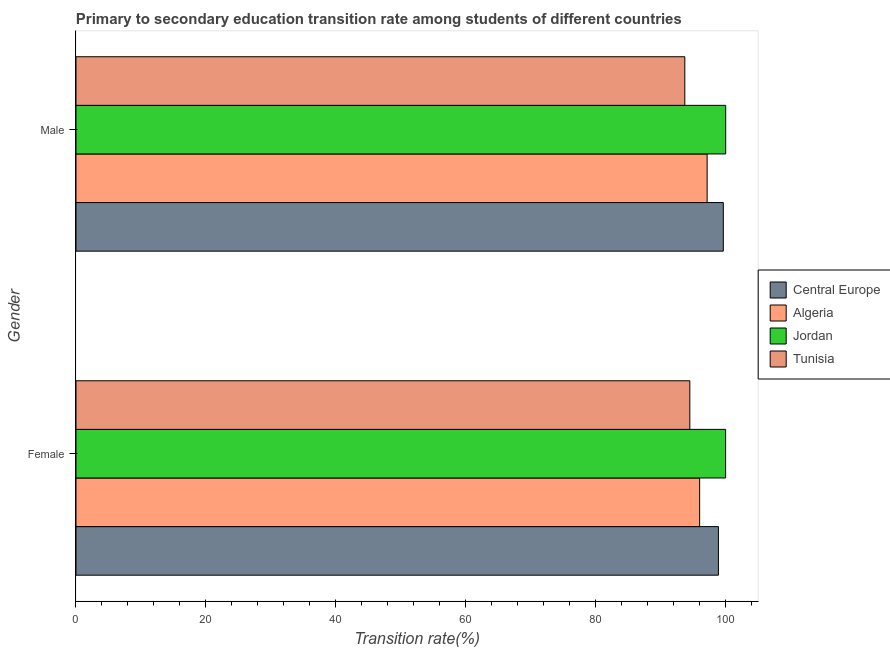How many different coloured bars are there?
Your response must be concise. 4. How many groups of bars are there?
Provide a succinct answer. 2. Are the number of bars on each tick of the Y-axis equal?
Offer a very short reply. Yes. What is the transition rate among male students in Algeria?
Offer a terse response. 97.14. Across all countries, what is the minimum transition rate among male students?
Keep it short and to the point. 93.71. In which country was the transition rate among male students maximum?
Provide a short and direct response. Jordan. In which country was the transition rate among male students minimum?
Your answer should be very brief. Tunisia. What is the total transition rate among female students in the graph?
Provide a succinct answer. 389.34. What is the difference between the transition rate among female students in Algeria and that in Tunisia?
Keep it short and to the point. 1.51. What is the difference between the transition rate among male students in Tunisia and the transition rate among female students in Jordan?
Offer a terse response. -6.28. What is the average transition rate among female students per country?
Provide a succinct answer. 97.33. What is the difference between the transition rate among male students and transition rate among female students in Tunisia?
Ensure brevity in your answer.  -0.77. In how many countries, is the transition rate among female students greater than 92 %?
Make the answer very short. 4. What is the ratio of the transition rate among male students in Algeria to that in Tunisia?
Keep it short and to the point. 1.04. In how many countries, is the transition rate among male students greater than the average transition rate among male students taken over all countries?
Provide a short and direct response. 2. What does the 1st bar from the top in Male represents?
Your response must be concise. Tunisia. What does the 3rd bar from the bottom in Male represents?
Your answer should be compact. Jordan. How many bars are there?
Ensure brevity in your answer.  8. Are all the bars in the graph horizontal?
Provide a short and direct response. Yes. How many countries are there in the graph?
Your answer should be compact. 4. Does the graph contain grids?
Make the answer very short. No. Where does the legend appear in the graph?
Provide a succinct answer. Center right. How many legend labels are there?
Make the answer very short. 4. What is the title of the graph?
Your answer should be very brief. Primary to secondary education transition rate among students of different countries. Does "Guam" appear as one of the legend labels in the graph?
Your answer should be compact. No. What is the label or title of the X-axis?
Make the answer very short. Transition rate(%). What is the Transition rate(%) of Central Europe in Female?
Offer a very short reply. 98.88. What is the Transition rate(%) in Algeria in Female?
Offer a very short reply. 95.99. What is the Transition rate(%) of Jordan in Female?
Your answer should be compact. 99.99. What is the Transition rate(%) in Tunisia in Female?
Offer a very short reply. 94.48. What is the Transition rate(%) in Central Europe in Male?
Ensure brevity in your answer.  99.63. What is the Transition rate(%) in Algeria in Male?
Your answer should be very brief. 97.14. What is the Transition rate(%) of Jordan in Male?
Offer a very short reply. 100. What is the Transition rate(%) of Tunisia in Male?
Make the answer very short. 93.71. Across all Gender, what is the maximum Transition rate(%) of Central Europe?
Offer a terse response. 99.63. Across all Gender, what is the maximum Transition rate(%) in Algeria?
Give a very brief answer. 97.14. Across all Gender, what is the maximum Transition rate(%) of Tunisia?
Your response must be concise. 94.48. Across all Gender, what is the minimum Transition rate(%) of Central Europe?
Give a very brief answer. 98.88. Across all Gender, what is the minimum Transition rate(%) of Algeria?
Keep it short and to the point. 95.99. Across all Gender, what is the minimum Transition rate(%) of Jordan?
Your answer should be very brief. 99.99. Across all Gender, what is the minimum Transition rate(%) in Tunisia?
Ensure brevity in your answer.  93.71. What is the total Transition rate(%) in Central Europe in the graph?
Your answer should be very brief. 198.51. What is the total Transition rate(%) in Algeria in the graph?
Give a very brief answer. 193.13. What is the total Transition rate(%) in Jordan in the graph?
Ensure brevity in your answer.  199.99. What is the total Transition rate(%) in Tunisia in the graph?
Offer a very short reply. 188.19. What is the difference between the Transition rate(%) of Central Europe in Female and that in Male?
Make the answer very short. -0.75. What is the difference between the Transition rate(%) in Algeria in Female and that in Male?
Offer a terse response. -1.15. What is the difference between the Transition rate(%) of Jordan in Female and that in Male?
Your response must be concise. -0.01. What is the difference between the Transition rate(%) in Tunisia in Female and that in Male?
Give a very brief answer. 0.77. What is the difference between the Transition rate(%) of Central Europe in Female and the Transition rate(%) of Algeria in Male?
Make the answer very short. 1.74. What is the difference between the Transition rate(%) of Central Europe in Female and the Transition rate(%) of Jordan in Male?
Ensure brevity in your answer.  -1.12. What is the difference between the Transition rate(%) of Central Europe in Female and the Transition rate(%) of Tunisia in Male?
Ensure brevity in your answer.  5.17. What is the difference between the Transition rate(%) of Algeria in Female and the Transition rate(%) of Jordan in Male?
Provide a succinct answer. -4.01. What is the difference between the Transition rate(%) in Algeria in Female and the Transition rate(%) in Tunisia in Male?
Your response must be concise. 2.28. What is the difference between the Transition rate(%) in Jordan in Female and the Transition rate(%) in Tunisia in Male?
Make the answer very short. 6.28. What is the average Transition rate(%) in Central Europe per Gender?
Your answer should be very brief. 99.26. What is the average Transition rate(%) of Algeria per Gender?
Provide a succinct answer. 96.57. What is the average Transition rate(%) of Jordan per Gender?
Your response must be concise. 99.99. What is the average Transition rate(%) in Tunisia per Gender?
Provide a succinct answer. 94.09. What is the difference between the Transition rate(%) of Central Europe and Transition rate(%) of Algeria in Female?
Offer a very short reply. 2.89. What is the difference between the Transition rate(%) in Central Europe and Transition rate(%) in Jordan in Female?
Your answer should be very brief. -1.11. What is the difference between the Transition rate(%) of Central Europe and Transition rate(%) of Tunisia in Female?
Offer a terse response. 4.4. What is the difference between the Transition rate(%) in Algeria and Transition rate(%) in Jordan in Female?
Provide a succinct answer. -4. What is the difference between the Transition rate(%) of Algeria and Transition rate(%) of Tunisia in Female?
Provide a short and direct response. 1.51. What is the difference between the Transition rate(%) of Jordan and Transition rate(%) of Tunisia in Female?
Ensure brevity in your answer.  5.51. What is the difference between the Transition rate(%) in Central Europe and Transition rate(%) in Algeria in Male?
Offer a very short reply. 2.49. What is the difference between the Transition rate(%) of Central Europe and Transition rate(%) of Jordan in Male?
Your answer should be very brief. -0.37. What is the difference between the Transition rate(%) in Central Europe and Transition rate(%) in Tunisia in Male?
Provide a succinct answer. 5.93. What is the difference between the Transition rate(%) in Algeria and Transition rate(%) in Jordan in Male?
Provide a short and direct response. -2.86. What is the difference between the Transition rate(%) in Algeria and Transition rate(%) in Tunisia in Male?
Provide a short and direct response. 3.44. What is the difference between the Transition rate(%) in Jordan and Transition rate(%) in Tunisia in Male?
Your answer should be very brief. 6.29. What is the ratio of the Transition rate(%) in Central Europe in Female to that in Male?
Your response must be concise. 0.99. What is the ratio of the Transition rate(%) of Algeria in Female to that in Male?
Offer a terse response. 0.99. What is the ratio of the Transition rate(%) of Tunisia in Female to that in Male?
Ensure brevity in your answer.  1.01. What is the difference between the highest and the second highest Transition rate(%) in Central Europe?
Keep it short and to the point. 0.75. What is the difference between the highest and the second highest Transition rate(%) in Algeria?
Provide a succinct answer. 1.15. What is the difference between the highest and the second highest Transition rate(%) of Jordan?
Your response must be concise. 0.01. What is the difference between the highest and the second highest Transition rate(%) of Tunisia?
Give a very brief answer. 0.77. What is the difference between the highest and the lowest Transition rate(%) of Central Europe?
Keep it short and to the point. 0.75. What is the difference between the highest and the lowest Transition rate(%) of Algeria?
Your answer should be compact. 1.15. What is the difference between the highest and the lowest Transition rate(%) of Jordan?
Your answer should be compact. 0.01. What is the difference between the highest and the lowest Transition rate(%) of Tunisia?
Keep it short and to the point. 0.77. 